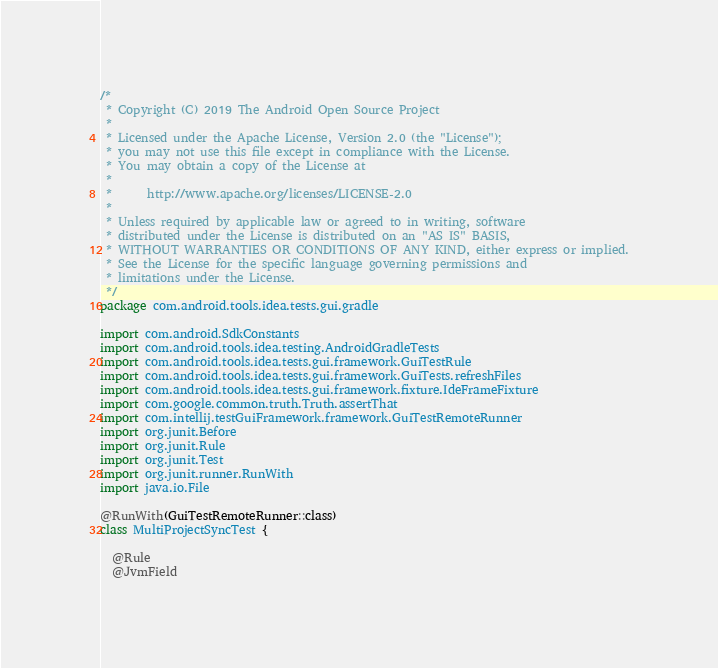<code> <loc_0><loc_0><loc_500><loc_500><_Kotlin_>/*
 * Copyright (C) 2019 The Android Open Source Project
 *
 * Licensed under the Apache License, Version 2.0 (the "License");
 * you may not use this file except in compliance with the License.
 * You may obtain a copy of the License at
 *
 *      http://www.apache.org/licenses/LICENSE-2.0
 *
 * Unless required by applicable law or agreed to in writing, software
 * distributed under the License is distributed on an "AS IS" BASIS,
 * WITHOUT WARRANTIES OR CONDITIONS OF ANY KIND, either express or implied.
 * See the License for the specific language governing permissions and
 * limitations under the License.
 */
package com.android.tools.idea.tests.gui.gradle

import com.android.SdkConstants
import com.android.tools.idea.testing.AndroidGradleTests
import com.android.tools.idea.tests.gui.framework.GuiTestRule
import com.android.tools.idea.tests.gui.framework.GuiTests.refreshFiles
import com.android.tools.idea.tests.gui.framework.fixture.IdeFrameFixture
import com.google.common.truth.Truth.assertThat
import com.intellij.testGuiFramework.framework.GuiTestRemoteRunner
import org.junit.Before
import org.junit.Rule
import org.junit.Test
import org.junit.runner.RunWith
import java.io.File

@RunWith(GuiTestRemoteRunner::class)
class MultiProjectSyncTest {

  @Rule
  @JvmField</code> 